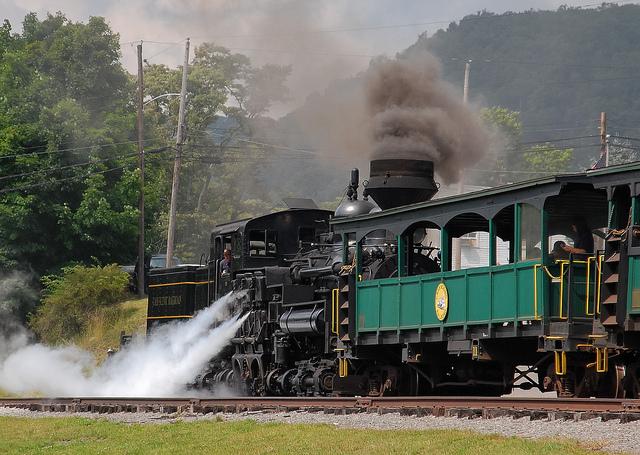Do you see any people in this train?
Concise answer only. Yes. Is there smoke coming from the top of the train?
Short answer required. Yes. Is it dark outside?
Keep it brief. No. 